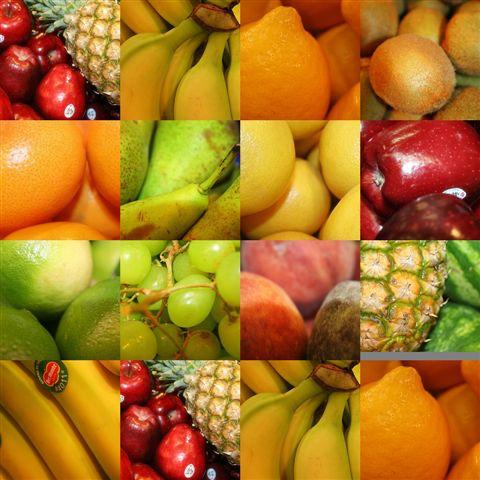How many kinds of fruit are on display?
Keep it brief. 10. How many pictures of bananas are there?
Be succinct. 3. How many different types of fruit are in the picture?
Give a very brief answer. 12. 